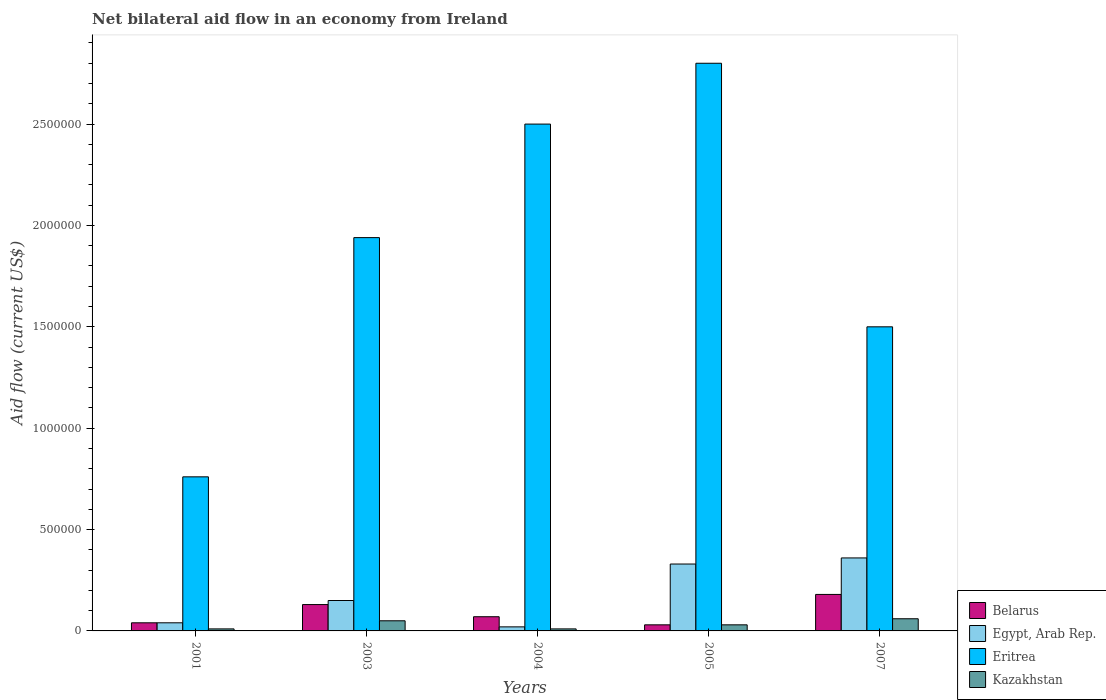How many different coloured bars are there?
Give a very brief answer. 4. Are the number of bars per tick equal to the number of legend labels?
Your answer should be compact. Yes. Are the number of bars on each tick of the X-axis equal?
Offer a terse response. Yes. How many bars are there on the 2nd tick from the right?
Offer a very short reply. 4. In how many cases, is the number of bars for a given year not equal to the number of legend labels?
Your answer should be very brief. 0. What is the net bilateral aid flow in Eritrea in 2007?
Provide a succinct answer. 1.50e+06. Across all years, what is the maximum net bilateral aid flow in Eritrea?
Ensure brevity in your answer.  2.80e+06. Across all years, what is the minimum net bilateral aid flow in Eritrea?
Your answer should be compact. 7.60e+05. In which year was the net bilateral aid flow in Eritrea maximum?
Your answer should be compact. 2005. In which year was the net bilateral aid flow in Kazakhstan minimum?
Offer a terse response. 2001. What is the difference between the net bilateral aid flow in Egypt, Arab Rep. in 2003 and that in 2005?
Offer a terse response. -1.80e+05. What is the difference between the net bilateral aid flow in Eritrea in 2005 and the net bilateral aid flow in Egypt, Arab Rep. in 2004?
Keep it short and to the point. 2.78e+06. What is the average net bilateral aid flow in Egypt, Arab Rep. per year?
Give a very brief answer. 1.80e+05. In the year 2005, what is the difference between the net bilateral aid flow in Eritrea and net bilateral aid flow in Kazakhstan?
Offer a very short reply. 2.77e+06. In how many years, is the net bilateral aid flow in Eritrea greater than 1300000 US$?
Provide a succinct answer. 4. What is the ratio of the net bilateral aid flow in Egypt, Arab Rep. in 2003 to that in 2007?
Make the answer very short. 0.42. Is the net bilateral aid flow in Kazakhstan in 2001 less than that in 2003?
Your answer should be compact. Yes. Is the difference between the net bilateral aid flow in Eritrea in 2005 and 2007 greater than the difference between the net bilateral aid flow in Kazakhstan in 2005 and 2007?
Offer a very short reply. Yes. What is the difference between the highest and the second highest net bilateral aid flow in Belarus?
Your answer should be compact. 5.00e+04. What is the difference between the highest and the lowest net bilateral aid flow in Eritrea?
Your answer should be very brief. 2.04e+06. Is the sum of the net bilateral aid flow in Egypt, Arab Rep. in 2001 and 2004 greater than the maximum net bilateral aid flow in Kazakhstan across all years?
Make the answer very short. No. Is it the case that in every year, the sum of the net bilateral aid flow in Kazakhstan and net bilateral aid flow in Egypt, Arab Rep. is greater than the sum of net bilateral aid flow in Eritrea and net bilateral aid flow in Belarus?
Your answer should be compact. No. What does the 1st bar from the left in 2004 represents?
Keep it short and to the point. Belarus. What does the 2nd bar from the right in 2001 represents?
Ensure brevity in your answer.  Eritrea. How many years are there in the graph?
Offer a terse response. 5. What is the difference between two consecutive major ticks on the Y-axis?
Give a very brief answer. 5.00e+05. Does the graph contain grids?
Give a very brief answer. No. Where does the legend appear in the graph?
Ensure brevity in your answer.  Bottom right. How are the legend labels stacked?
Your answer should be very brief. Vertical. What is the title of the graph?
Your answer should be very brief. Net bilateral aid flow in an economy from Ireland. Does "India" appear as one of the legend labels in the graph?
Your response must be concise. No. What is the label or title of the X-axis?
Offer a terse response. Years. What is the Aid flow (current US$) of Eritrea in 2001?
Provide a short and direct response. 7.60e+05. What is the Aid flow (current US$) of Egypt, Arab Rep. in 2003?
Your answer should be compact. 1.50e+05. What is the Aid flow (current US$) in Eritrea in 2003?
Provide a short and direct response. 1.94e+06. What is the Aid flow (current US$) of Belarus in 2004?
Offer a very short reply. 7.00e+04. What is the Aid flow (current US$) of Egypt, Arab Rep. in 2004?
Offer a terse response. 2.00e+04. What is the Aid flow (current US$) in Eritrea in 2004?
Give a very brief answer. 2.50e+06. What is the Aid flow (current US$) in Belarus in 2005?
Your response must be concise. 3.00e+04. What is the Aid flow (current US$) in Eritrea in 2005?
Provide a succinct answer. 2.80e+06. What is the Aid flow (current US$) of Kazakhstan in 2005?
Provide a short and direct response. 3.00e+04. What is the Aid flow (current US$) of Belarus in 2007?
Your answer should be very brief. 1.80e+05. What is the Aid flow (current US$) of Egypt, Arab Rep. in 2007?
Your answer should be very brief. 3.60e+05. What is the Aid flow (current US$) of Eritrea in 2007?
Keep it short and to the point. 1.50e+06. Across all years, what is the maximum Aid flow (current US$) in Eritrea?
Ensure brevity in your answer.  2.80e+06. Across all years, what is the minimum Aid flow (current US$) in Eritrea?
Give a very brief answer. 7.60e+05. Across all years, what is the minimum Aid flow (current US$) of Kazakhstan?
Make the answer very short. 10000. What is the total Aid flow (current US$) of Belarus in the graph?
Provide a short and direct response. 4.50e+05. What is the total Aid flow (current US$) of Eritrea in the graph?
Ensure brevity in your answer.  9.50e+06. What is the total Aid flow (current US$) in Kazakhstan in the graph?
Make the answer very short. 1.60e+05. What is the difference between the Aid flow (current US$) in Eritrea in 2001 and that in 2003?
Make the answer very short. -1.18e+06. What is the difference between the Aid flow (current US$) of Kazakhstan in 2001 and that in 2003?
Your answer should be compact. -4.00e+04. What is the difference between the Aid flow (current US$) of Eritrea in 2001 and that in 2004?
Make the answer very short. -1.74e+06. What is the difference between the Aid flow (current US$) of Kazakhstan in 2001 and that in 2004?
Give a very brief answer. 0. What is the difference between the Aid flow (current US$) of Egypt, Arab Rep. in 2001 and that in 2005?
Your answer should be very brief. -2.90e+05. What is the difference between the Aid flow (current US$) of Eritrea in 2001 and that in 2005?
Provide a succinct answer. -2.04e+06. What is the difference between the Aid flow (current US$) in Kazakhstan in 2001 and that in 2005?
Provide a short and direct response. -2.00e+04. What is the difference between the Aid flow (current US$) of Belarus in 2001 and that in 2007?
Your answer should be very brief. -1.40e+05. What is the difference between the Aid flow (current US$) of Egypt, Arab Rep. in 2001 and that in 2007?
Give a very brief answer. -3.20e+05. What is the difference between the Aid flow (current US$) of Eritrea in 2001 and that in 2007?
Make the answer very short. -7.40e+05. What is the difference between the Aid flow (current US$) in Egypt, Arab Rep. in 2003 and that in 2004?
Ensure brevity in your answer.  1.30e+05. What is the difference between the Aid flow (current US$) in Eritrea in 2003 and that in 2004?
Your response must be concise. -5.60e+05. What is the difference between the Aid flow (current US$) of Kazakhstan in 2003 and that in 2004?
Keep it short and to the point. 4.00e+04. What is the difference between the Aid flow (current US$) in Belarus in 2003 and that in 2005?
Your answer should be very brief. 1.00e+05. What is the difference between the Aid flow (current US$) in Eritrea in 2003 and that in 2005?
Your response must be concise. -8.60e+05. What is the difference between the Aid flow (current US$) of Egypt, Arab Rep. in 2004 and that in 2005?
Ensure brevity in your answer.  -3.10e+05. What is the difference between the Aid flow (current US$) in Eritrea in 2004 and that in 2005?
Offer a very short reply. -3.00e+05. What is the difference between the Aid flow (current US$) of Egypt, Arab Rep. in 2004 and that in 2007?
Make the answer very short. -3.40e+05. What is the difference between the Aid flow (current US$) of Eritrea in 2004 and that in 2007?
Offer a terse response. 1.00e+06. What is the difference between the Aid flow (current US$) of Egypt, Arab Rep. in 2005 and that in 2007?
Give a very brief answer. -3.00e+04. What is the difference between the Aid flow (current US$) of Eritrea in 2005 and that in 2007?
Provide a short and direct response. 1.30e+06. What is the difference between the Aid flow (current US$) of Kazakhstan in 2005 and that in 2007?
Your answer should be compact. -3.00e+04. What is the difference between the Aid flow (current US$) in Belarus in 2001 and the Aid flow (current US$) in Eritrea in 2003?
Give a very brief answer. -1.90e+06. What is the difference between the Aid flow (current US$) in Belarus in 2001 and the Aid flow (current US$) in Kazakhstan in 2003?
Offer a terse response. -10000. What is the difference between the Aid flow (current US$) in Egypt, Arab Rep. in 2001 and the Aid flow (current US$) in Eritrea in 2003?
Provide a short and direct response. -1.90e+06. What is the difference between the Aid flow (current US$) in Egypt, Arab Rep. in 2001 and the Aid flow (current US$) in Kazakhstan in 2003?
Give a very brief answer. -10000. What is the difference between the Aid flow (current US$) of Eritrea in 2001 and the Aid flow (current US$) of Kazakhstan in 2003?
Your answer should be compact. 7.10e+05. What is the difference between the Aid flow (current US$) in Belarus in 2001 and the Aid flow (current US$) in Egypt, Arab Rep. in 2004?
Ensure brevity in your answer.  2.00e+04. What is the difference between the Aid flow (current US$) of Belarus in 2001 and the Aid flow (current US$) of Eritrea in 2004?
Provide a succinct answer. -2.46e+06. What is the difference between the Aid flow (current US$) of Egypt, Arab Rep. in 2001 and the Aid flow (current US$) of Eritrea in 2004?
Ensure brevity in your answer.  -2.46e+06. What is the difference between the Aid flow (current US$) of Egypt, Arab Rep. in 2001 and the Aid flow (current US$) of Kazakhstan in 2004?
Ensure brevity in your answer.  3.00e+04. What is the difference between the Aid flow (current US$) of Eritrea in 2001 and the Aid flow (current US$) of Kazakhstan in 2004?
Your answer should be compact. 7.50e+05. What is the difference between the Aid flow (current US$) of Belarus in 2001 and the Aid flow (current US$) of Egypt, Arab Rep. in 2005?
Provide a succinct answer. -2.90e+05. What is the difference between the Aid flow (current US$) in Belarus in 2001 and the Aid flow (current US$) in Eritrea in 2005?
Ensure brevity in your answer.  -2.76e+06. What is the difference between the Aid flow (current US$) in Belarus in 2001 and the Aid flow (current US$) in Kazakhstan in 2005?
Your response must be concise. 10000. What is the difference between the Aid flow (current US$) of Egypt, Arab Rep. in 2001 and the Aid flow (current US$) of Eritrea in 2005?
Your answer should be very brief. -2.76e+06. What is the difference between the Aid flow (current US$) of Egypt, Arab Rep. in 2001 and the Aid flow (current US$) of Kazakhstan in 2005?
Provide a short and direct response. 10000. What is the difference between the Aid flow (current US$) in Eritrea in 2001 and the Aid flow (current US$) in Kazakhstan in 2005?
Give a very brief answer. 7.30e+05. What is the difference between the Aid flow (current US$) in Belarus in 2001 and the Aid flow (current US$) in Egypt, Arab Rep. in 2007?
Make the answer very short. -3.20e+05. What is the difference between the Aid flow (current US$) in Belarus in 2001 and the Aid flow (current US$) in Eritrea in 2007?
Your answer should be compact. -1.46e+06. What is the difference between the Aid flow (current US$) of Egypt, Arab Rep. in 2001 and the Aid flow (current US$) of Eritrea in 2007?
Offer a terse response. -1.46e+06. What is the difference between the Aid flow (current US$) in Egypt, Arab Rep. in 2001 and the Aid flow (current US$) in Kazakhstan in 2007?
Give a very brief answer. -2.00e+04. What is the difference between the Aid flow (current US$) of Belarus in 2003 and the Aid flow (current US$) of Egypt, Arab Rep. in 2004?
Keep it short and to the point. 1.10e+05. What is the difference between the Aid flow (current US$) of Belarus in 2003 and the Aid flow (current US$) of Eritrea in 2004?
Offer a very short reply. -2.37e+06. What is the difference between the Aid flow (current US$) of Egypt, Arab Rep. in 2003 and the Aid flow (current US$) of Eritrea in 2004?
Make the answer very short. -2.35e+06. What is the difference between the Aid flow (current US$) in Eritrea in 2003 and the Aid flow (current US$) in Kazakhstan in 2004?
Offer a terse response. 1.93e+06. What is the difference between the Aid flow (current US$) in Belarus in 2003 and the Aid flow (current US$) in Eritrea in 2005?
Your response must be concise. -2.67e+06. What is the difference between the Aid flow (current US$) of Belarus in 2003 and the Aid flow (current US$) of Kazakhstan in 2005?
Offer a very short reply. 1.00e+05. What is the difference between the Aid flow (current US$) of Egypt, Arab Rep. in 2003 and the Aid flow (current US$) of Eritrea in 2005?
Provide a succinct answer. -2.65e+06. What is the difference between the Aid flow (current US$) of Egypt, Arab Rep. in 2003 and the Aid flow (current US$) of Kazakhstan in 2005?
Provide a short and direct response. 1.20e+05. What is the difference between the Aid flow (current US$) in Eritrea in 2003 and the Aid flow (current US$) in Kazakhstan in 2005?
Provide a succinct answer. 1.91e+06. What is the difference between the Aid flow (current US$) of Belarus in 2003 and the Aid flow (current US$) of Eritrea in 2007?
Your answer should be very brief. -1.37e+06. What is the difference between the Aid flow (current US$) in Egypt, Arab Rep. in 2003 and the Aid flow (current US$) in Eritrea in 2007?
Your response must be concise. -1.35e+06. What is the difference between the Aid flow (current US$) in Egypt, Arab Rep. in 2003 and the Aid flow (current US$) in Kazakhstan in 2007?
Ensure brevity in your answer.  9.00e+04. What is the difference between the Aid flow (current US$) of Eritrea in 2003 and the Aid flow (current US$) of Kazakhstan in 2007?
Offer a very short reply. 1.88e+06. What is the difference between the Aid flow (current US$) in Belarus in 2004 and the Aid flow (current US$) in Eritrea in 2005?
Make the answer very short. -2.73e+06. What is the difference between the Aid flow (current US$) of Belarus in 2004 and the Aid flow (current US$) of Kazakhstan in 2005?
Offer a very short reply. 4.00e+04. What is the difference between the Aid flow (current US$) of Egypt, Arab Rep. in 2004 and the Aid flow (current US$) of Eritrea in 2005?
Make the answer very short. -2.78e+06. What is the difference between the Aid flow (current US$) of Eritrea in 2004 and the Aid flow (current US$) of Kazakhstan in 2005?
Offer a very short reply. 2.47e+06. What is the difference between the Aid flow (current US$) in Belarus in 2004 and the Aid flow (current US$) in Eritrea in 2007?
Make the answer very short. -1.43e+06. What is the difference between the Aid flow (current US$) in Egypt, Arab Rep. in 2004 and the Aid flow (current US$) in Eritrea in 2007?
Offer a terse response. -1.48e+06. What is the difference between the Aid flow (current US$) of Eritrea in 2004 and the Aid flow (current US$) of Kazakhstan in 2007?
Ensure brevity in your answer.  2.44e+06. What is the difference between the Aid flow (current US$) in Belarus in 2005 and the Aid flow (current US$) in Egypt, Arab Rep. in 2007?
Your answer should be very brief. -3.30e+05. What is the difference between the Aid flow (current US$) of Belarus in 2005 and the Aid flow (current US$) of Eritrea in 2007?
Offer a very short reply. -1.47e+06. What is the difference between the Aid flow (current US$) in Belarus in 2005 and the Aid flow (current US$) in Kazakhstan in 2007?
Give a very brief answer. -3.00e+04. What is the difference between the Aid flow (current US$) of Egypt, Arab Rep. in 2005 and the Aid flow (current US$) of Eritrea in 2007?
Your response must be concise. -1.17e+06. What is the difference between the Aid flow (current US$) of Eritrea in 2005 and the Aid flow (current US$) of Kazakhstan in 2007?
Your answer should be very brief. 2.74e+06. What is the average Aid flow (current US$) in Belarus per year?
Offer a terse response. 9.00e+04. What is the average Aid flow (current US$) of Eritrea per year?
Give a very brief answer. 1.90e+06. What is the average Aid flow (current US$) in Kazakhstan per year?
Your answer should be compact. 3.20e+04. In the year 2001, what is the difference between the Aid flow (current US$) of Belarus and Aid flow (current US$) of Egypt, Arab Rep.?
Your response must be concise. 0. In the year 2001, what is the difference between the Aid flow (current US$) in Belarus and Aid flow (current US$) in Eritrea?
Offer a terse response. -7.20e+05. In the year 2001, what is the difference between the Aid flow (current US$) of Belarus and Aid flow (current US$) of Kazakhstan?
Your response must be concise. 3.00e+04. In the year 2001, what is the difference between the Aid flow (current US$) in Egypt, Arab Rep. and Aid flow (current US$) in Eritrea?
Provide a short and direct response. -7.20e+05. In the year 2001, what is the difference between the Aid flow (current US$) of Eritrea and Aid flow (current US$) of Kazakhstan?
Your answer should be compact. 7.50e+05. In the year 2003, what is the difference between the Aid flow (current US$) of Belarus and Aid flow (current US$) of Eritrea?
Keep it short and to the point. -1.81e+06. In the year 2003, what is the difference between the Aid flow (current US$) in Egypt, Arab Rep. and Aid flow (current US$) in Eritrea?
Offer a very short reply. -1.79e+06. In the year 2003, what is the difference between the Aid flow (current US$) in Eritrea and Aid flow (current US$) in Kazakhstan?
Provide a succinct answer. 1.89e+06. In the year 2004, what is the difference between the Aid flow (current US$) of Belarus and Aid flow (current US$) of Egypt, Arab Rep.?
Your answer should be very brief. 5.00e+04. In the year 2004, what is the difference between the Aid flow (current US$) in Belarus and Aid flow (current US$) in Eritrea?
Give a very brief answer. -2.43e+06. In the year 2004, what is the difference between the Aid flow (current US$) in Belarus and Aid flow (current US$) in Kazakhstan?
Offer a terse response. 6.00e+04. In the year 2004, what is the difference between the Aid flow (current US$) in Egypt, Arab Rep. and Aid flow (current US$) in Eritrea?
Ensure brevity in your answer.  -2.48e+06. In the year 2004, what is the difference between the Aid flow (current US$) of Eritrea and Aid flow (current US$) of Kazakhstan?
Keep it short and to the point. 2.49e+06. In the year 2005, what is the difference between the Aid flow (current US$) of Belarus and Aid flow (current US$) of Eritrea?
Ensure brevity in your answer.  -2.77e+06. In the year 2005, what is the difference between the Aid flow (current US$) of Belarus and Aid flow (current US$) of Kazakhstan?
Provide a succinct answer. 0. In the year 2005, what is the difference between the Aid flow (current US$) of Egypt, Arab Rep. and Aid flow (current US$) of Eritrea?
Your answer should be very brief. -2.47e+06. In the year 2005, what is the difference between the Aid flow (current US$) of Egypt, Arab Rep. and Aid flow (current US$) of Kazakhstan?
Ensure brevity in your answer.  3.00e+05. In the year 2005, what is the difference between the Aid flow (current US$) in Eritrea and Aid flow (current US$) in Kazakhstan?
Your answer should be very brief. 2.77e+06. In the year 2007, what is the difference between the Aid flow (current US$) in Belarus and Aid flow (current US$) in Eritrea?
Provide a succinct answer. -1.32e+06. In the year 2007, what is the difference between the Aid flow (current US$) of Egypt, Arab Rep. and Aid flow (current US$) of Eritrea?
Offer a terse response. -1.14e+06. In the year 2007, what is the difference between the Aid flow (current US$) of Eritrea and Aid flow (current US$) of Kazakhstan?
Provide a short and direct response. 1.44e+06. What is the ratio of the Aid flow (current US$) in Belarus in 2001 to that in 2003?
Your answer should be very brief. 0.31. What is the ratio of the Aid flow (current US$) in Egypt, Arab Rep. in 2001 to that in 2003?
Offer a terse response. 0.27. What is the ratio of the Aid flow (current US$) in Eritrea in 2001 to that in 2003?
Give a very brief answer. 0.39. What is the ratio of the Aid flow (current US$) in Kazakhstan in 2001 to that in 2003?
Make the answer very short. 0.2. What is the ratio of the Aid flow (current US$) in Egypt, Arab Rep. in 2001 to that in 2004?
Ensure brevity in your answer.  2. What is the ratio of the Aid flow (current US$) of Eritrea in 2001 to that in 2004?
Keep it short and to the point. 0.3. What is the ratio of the Aid flow (current US$) in Kazakhstan in 2001 to that in 2004?
Give a very brief answer. 1. What is the ratio of the Aid flow (current US$) of Belarus in 2001 to that in 2005?
Provide a succinct answer. 1.33. What is the ratio of the Aid flow (current US$) in Egypt, Arab Rep. in 2001 to that in 2005?
Your answer should be very brief. 0.12. What is the ratio of the Aid flow (current US$) of Eritrea in 2001 to that in 2005?
Your response must be concise. 0.27. What is the ratio of the Aid flow (current US$) in Kazakhstan in 2001 to that in 2005?
Offer a terse response. 0.33. What is the ratio of the Aid flow (current US$) in Belarus in 2001 to that in 2007?
Your answer should be compact. 0.22. What is the ratio of the Aid flow (current US$) in Eritrea in 2001 to that in 2007?
Give a very brief answer. 0.51. What is the ratio of the Aid flow (current US$) of Belarus in 2003 to that in 2004?
Give a very brief answer. 1.86. What is the ratio of the Aid flow (current US$) in Eritrea in 2003 to that in 2004?
Give a very brief answer. 0.78. What is the ratio of the Aid flow (current US$) in Kazakhstan in 2003 to that in 2004?
Your answer should be compact. 5. What is the ratio of the Aid flow (current US$) in Belarus in 2003 to that in 2005?
Make the answer very short. 4.33. What is the ratio of the Aid flow (current US$) in Egypt, Arab Rep. in 2003 to that in 2005?
Your answer should be very brief. 0.45. What is the ratio of the Aid flow (current US$) of Eritrea in 2003 to that in 2005?
Your answer should be very brief. 0.69. What is the ratio of the Aid flow (current US$) in Kazakhstan in 2003 to that in 2005?
Your answer should be very brief. 1.67. What is the ratio of the Aid flow (current US$) in Belarus in 2003 to that in 2007?
Your answer should be compact. 0.72. What is the ratio of the Aid flow (current US$) of Egypt, Arab Rep. in 2003 to that in 2007?
Your response must be concise. 0.42. What is the ratio of the Aid flow (current US$) of Eritrea in 2003 to that in 2007?
Offer a terse response. 1.29. What is the ratio of the Aid flow (current US$) in Kazakhstan in 2003 to that in 2007?
Provide a short and direct response. 0.83. What is the ratio of the Aid flow (current US$) in Belarus in 2004 to that in 2005?
Your response must be concise. 2.33. What is the ratio of the Aid flow (current US$) in Egypt, Arab Rep. in 2004 to that in 2005?
Ensure brevity in your answer.  0.06. What is the ratio of the Aid flow (current US$) in Eritrea in 2004 to that in 2005?
Your answer should be very brief. 0.89. What is the ratio of the Aid flow (current US$) of Kazakhstan in 2004 to that in 2005?
Keep it short and to the point. 0.33. What is the ratio of the Aid flow (current US$) of Belarus in 2004 to that in 2007?
Your answer should be compact. 0.39. What is the ratio of the Aid flow (current US$) in Egypt, Arab Rep. in 2004 to that in 2007?
Your response must be concise. 0.06. What is the ratio of the Aid flow (current US$) in Kazakhstan in 2004 to that in 2007?
Keep it short and to the point. 0.17. What is the ratio of the Aid flow (current US$) in Eritrea in 2005 to that in 2007?
Make the answer very short. 1.87. What is the difference between the highest and the second highest Aid flow (current US$) of Eritrea?
Your response must be concise. 3.00e+05. What is the difference between the highest and the lowest Aid flow (current US$) of Belarus?
Your response must be concise. 1.50e+05. What is the difference between the highest and the lowest Aid flow (current US$) in Egypt, Arab Rep.?
Provide a succinct answer. 3.40e+05. What is the difference between the highest and the lowest Aid flow (current US$) in Eritrea?
Provide a short and direct response. 2.04e+06. 